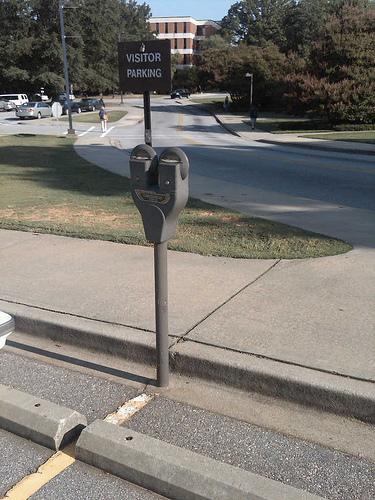How many signs do you see?
Quick response, please. 1. Is this free parking?
Quick response, please. No. What is the object in the center?
Concise answer only. Parking meter. Who is allowed to park here?
Write a very short answer. Visitors. 